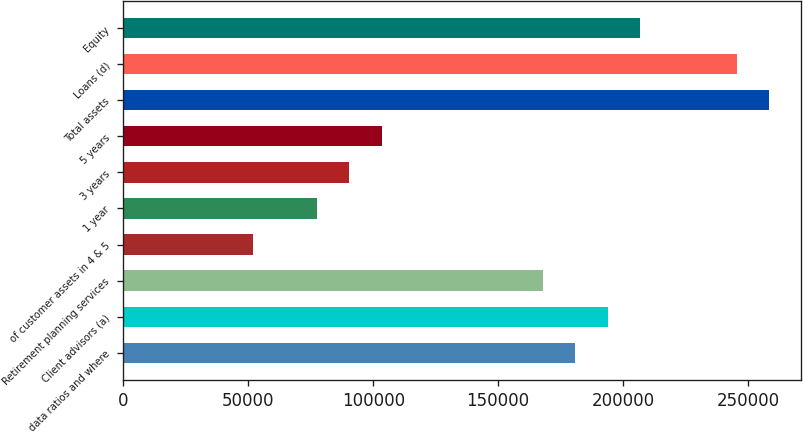Convert chart. <chart><loc_0><loc_0><loc_500><loc_500><bar_chart><fcel>data ratios and where<fcel>Client advisors (a)<fcel>Retirement planning services<fcel>of customer assets in 4 & 5<fcel>1 year<fcel>3 years<fcel>5 years<fcel>Total assets<fcel>Loans (d)<fcel>Equity<nl><fcel>180891<fcel>193812<fcel>167970<fcel>51683.2<fcel>77524.8<fcel>90445.6<fcel>103366<fcel>258416<fcel>245495<fcel>206733<nl></chart> 